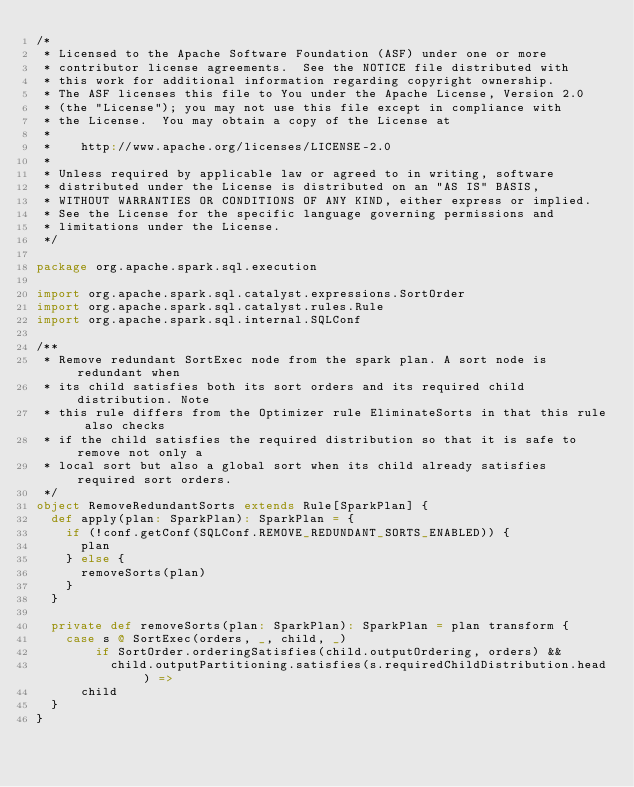Convert code to text. <code><loc_0><loc_0><loc_500><loc_500><_Scala_>/*
 * Licensed to the Apache Software Foundation (ASF) under one or more
 * contributor license agreements.  See the NOTICE file distributed with
 * this work for additional information regarding copyright ownership.
 * The ASF licenses this file to You under the Apache License, Version 2.0
 * (the "License"); you may not use this file except in compliance with
 * the License.  You may obtain a copy of the License at
 *
 *    http://www.apache.org/licenses/LICENSE-2.0
 *
 * Unless required by applicable law or agreed to in writing, software
 * distributed under the License is distributed on an "AS IS" BASIS,
 * WITHOUT WARRANTIES OR CONDITIONS OF ANY KIND, either express or implied.
 * See the License for the specific language governing permissions and
 * limitations under the License.
 */

package org.apache.spark.sql.execution

import org.apache.spark.sql.catalyst.expressions.SortOrder
import org.apache.spark.sql.catalyst.rules.Rule
import org.apache.spark.sql.internal.SQLConf

/**
 * Remove redundant SortExec node from the spark plan. A sort node is redundant when
 * its child satisfies both its sort orders and its required child distribution. Note
 * this rule differs from the Optimizer rule EliminateSorts in that this rule also checks
 * if the child satisfies the required distribution so that it is safe to remove not only a
 * local sort but also a global sort when its child already satisfies required sort orders.
 */
object RemoveRedundantSorts extends Rule[SparkPlan] {
  def apply(plan: SparkPlan): SparkPlan = {
    if (!conf.getConf(SQLConf.REMOVE_REDUNDANT_SORTS_ENABLED)) {
      plan
    } else {
      removeSorts(plan)
    }
  }

  private def removeSorts(plan: SparkPlan): SparkPlan = plan transform {
    case s @ SortExec(orders, _, child, _)
        if SortOrder.orderingSatisfies(child.outputOrdering, orders) &&
          child.outputPartitioning.satisfies(s.requiredChildDistribution.head) =>
      child
  }
}
</code> 